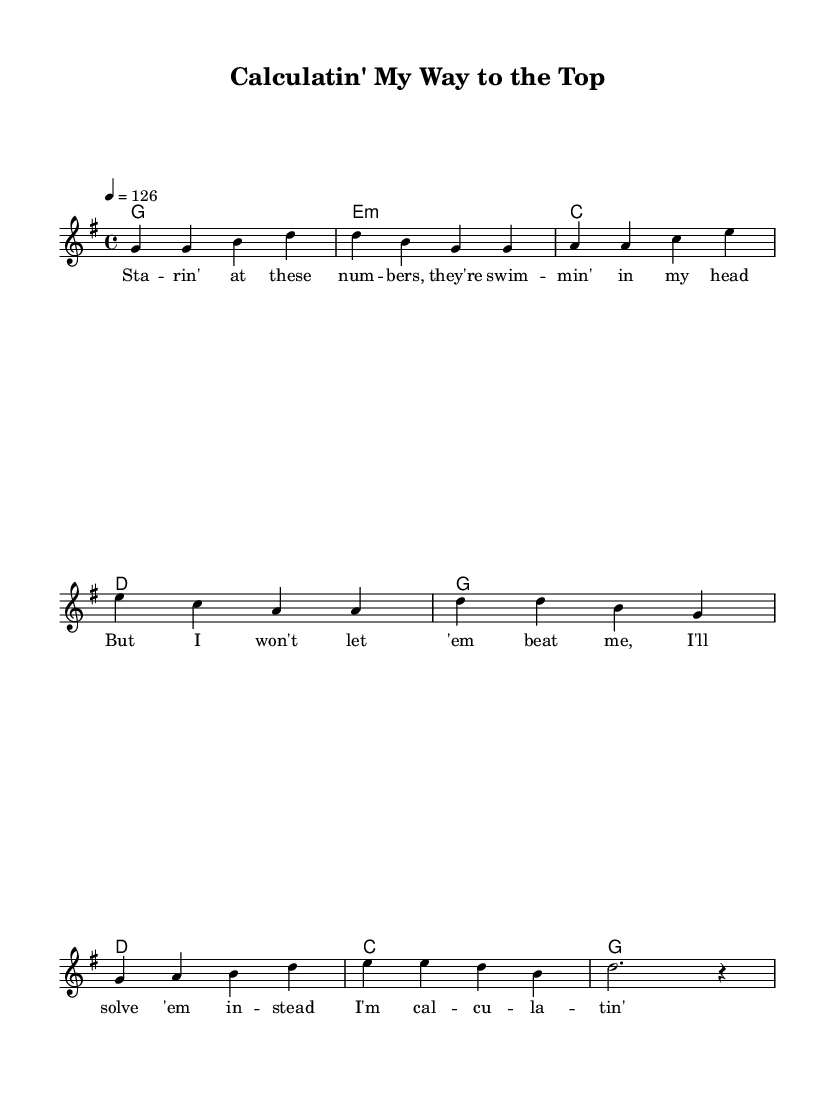What is the key signature of this music? The key signature is shown at the beginning of the sheet music, indicating G major, which has one sharp.
Answer: G major What is the time signature? The time signature, located at the beginning of the music, indicates that there are four beats per measure, which is represented as 4/4.
Answer: 4/4 What is the tempo marking? The tempo marking indicates a speed of 126 beats per minute, which is stated as "4 = 126" at the start of the score.
Answer: 126 How many measures are in the verse section? By counting the measures in the melody section labeled as "Verse," we find that there are four measures before transitioning to the chorus.
Answer: 4 What is the rhyme scheme of the chorus lyrics? By analyzing the chorus lyrics, we observe that the lines and their endings create a repeated pattern, which shows the rhyme scheme as "AABB."
Answer: AABB Which chord is primarily used in both the verse and chorus? By examining the chord progression indicated in the harmonies section, we see that the chord G is used in both sections multiple times.
Answer: G How does the music reflect the theme of overcoming challenges? The upbeat tempo and determined lyrics, along with the resilient chord progressions, convey a positive feeling symbolizing perseverance in academic challenges.
Answer: Perseverance 